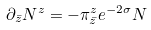<formula> <loc_0><loc_0><loc_500><loc_500>\partial _ { \bar { z } } N ^ { z } = - \pi ^ { z } _ { \bar { z } } e ^ { - 2 \sigma } N</formula> 